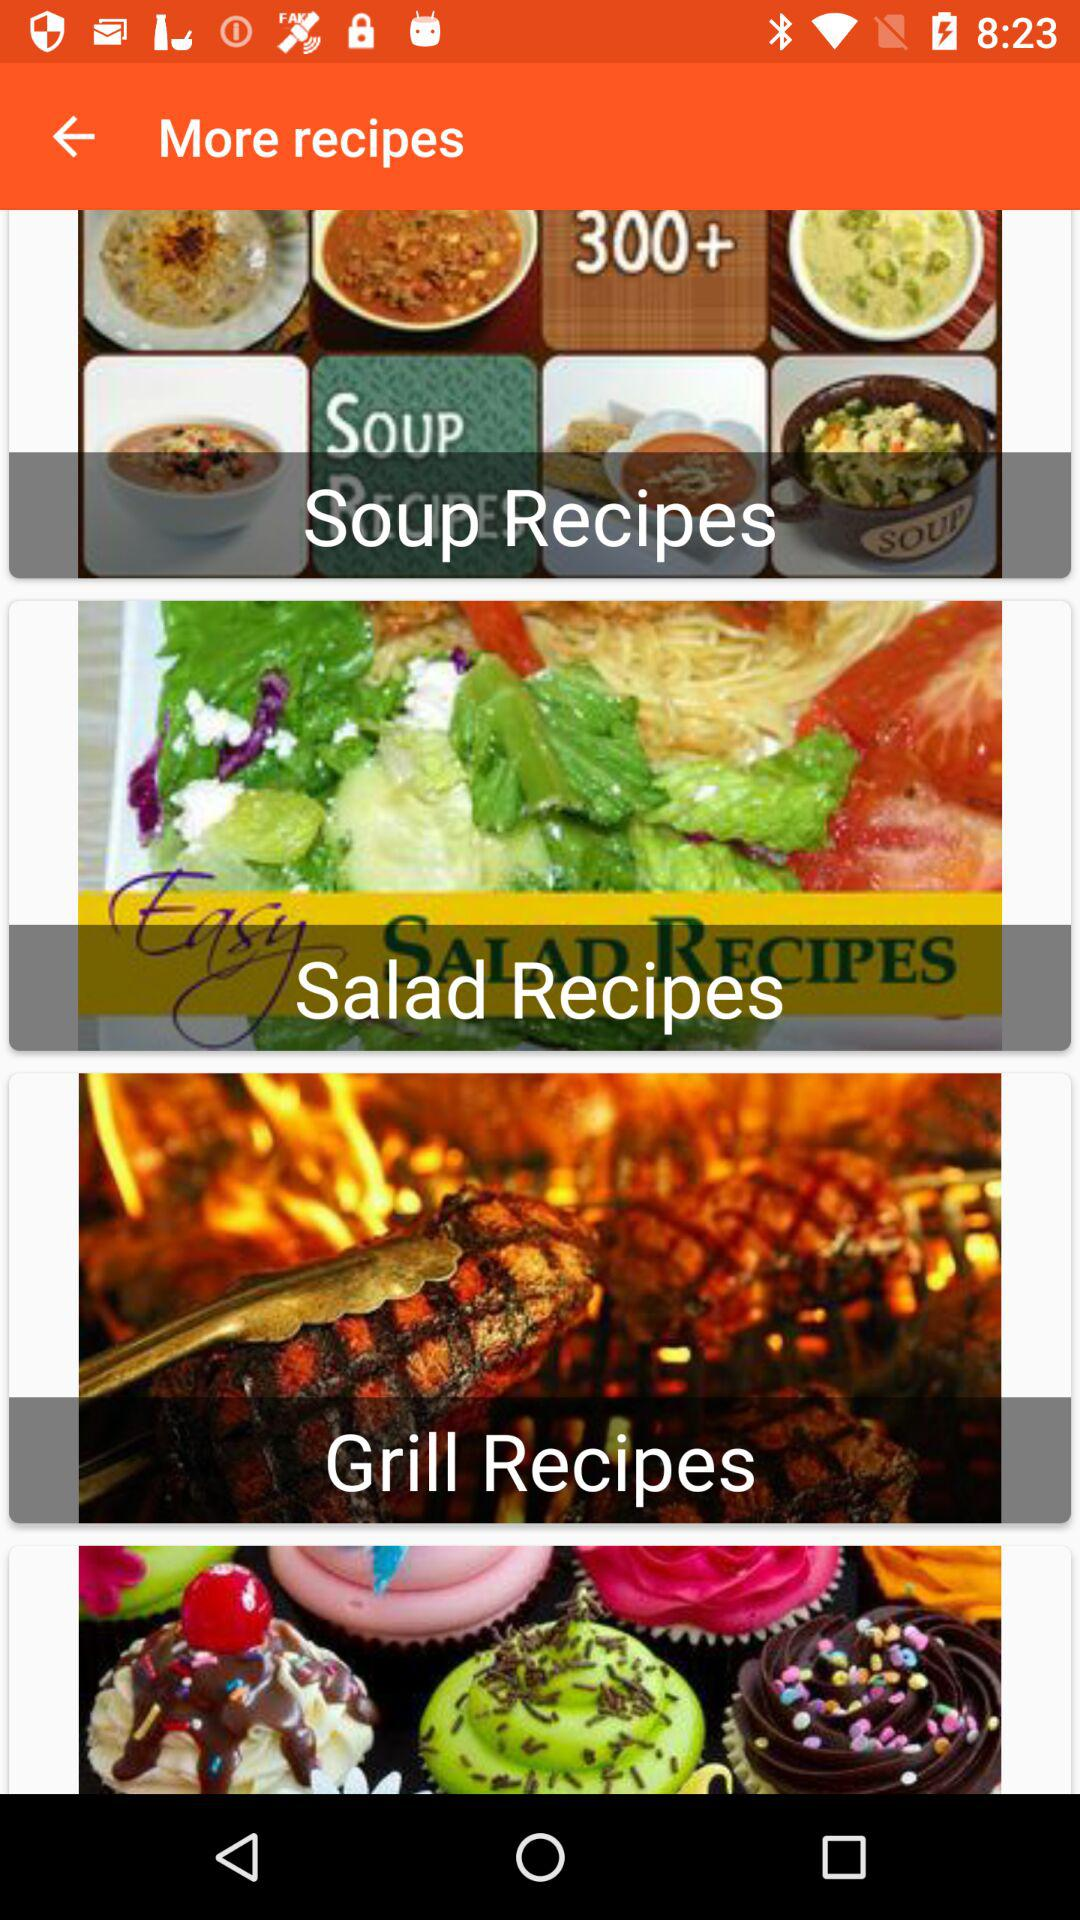What are the different varieties of the shown recipes? The different varieties are "Soup Recipes", "Salad Recipes" and "Grill Recipes". 